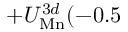<formula> <loc_0><loc_0><loc_500><loc_500>+ U _ { M n } ^ { 3 d } ( - 0 . 5</formula> 